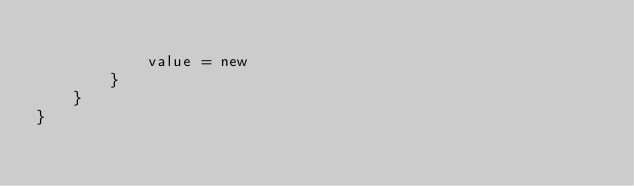Convert code to text. <code><loc_0><loc_0><loc_500><loc_500><_Kotlin_>
            value = new
        }
    }
}
</code> 